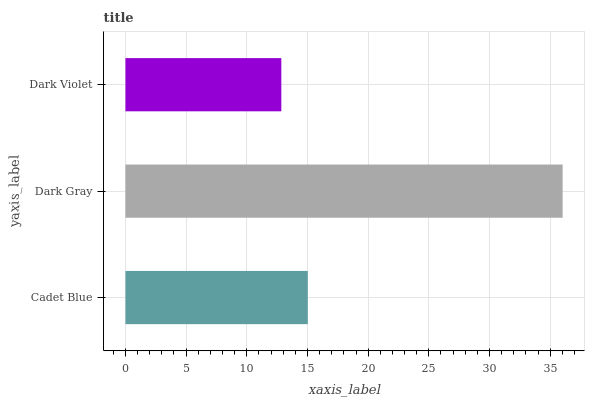Is Dark Violet the minimum?
Answer yes or no. Yes. Is Dark Gray the maximum?
Answer yes or no. Yes. Is Dark Gray the minimum?
Answer yes or no. No. Is Dark Violet the maximum?
Answer yes or no. No. Is Dark Gray greater than Dark Violet?
Answer yes or no. Yes. Is Dark Violet less than Dark Gray?
Answer yes or no. Yes. Is Dark Violet greater than Dark Gray?
Answer yes or no. No. Is Dark Gray less than Dark Violet?
Answer yes or no. No. Is Cadet Blue the high median?
Answer yes or no. Yes. Is Cadet Blue the low median?
Answer yes or no. Yes. Is Dark Violet the high median?
Answer yes or no. No. Is Dark Gray the low median?
Answer yes or no. No. 